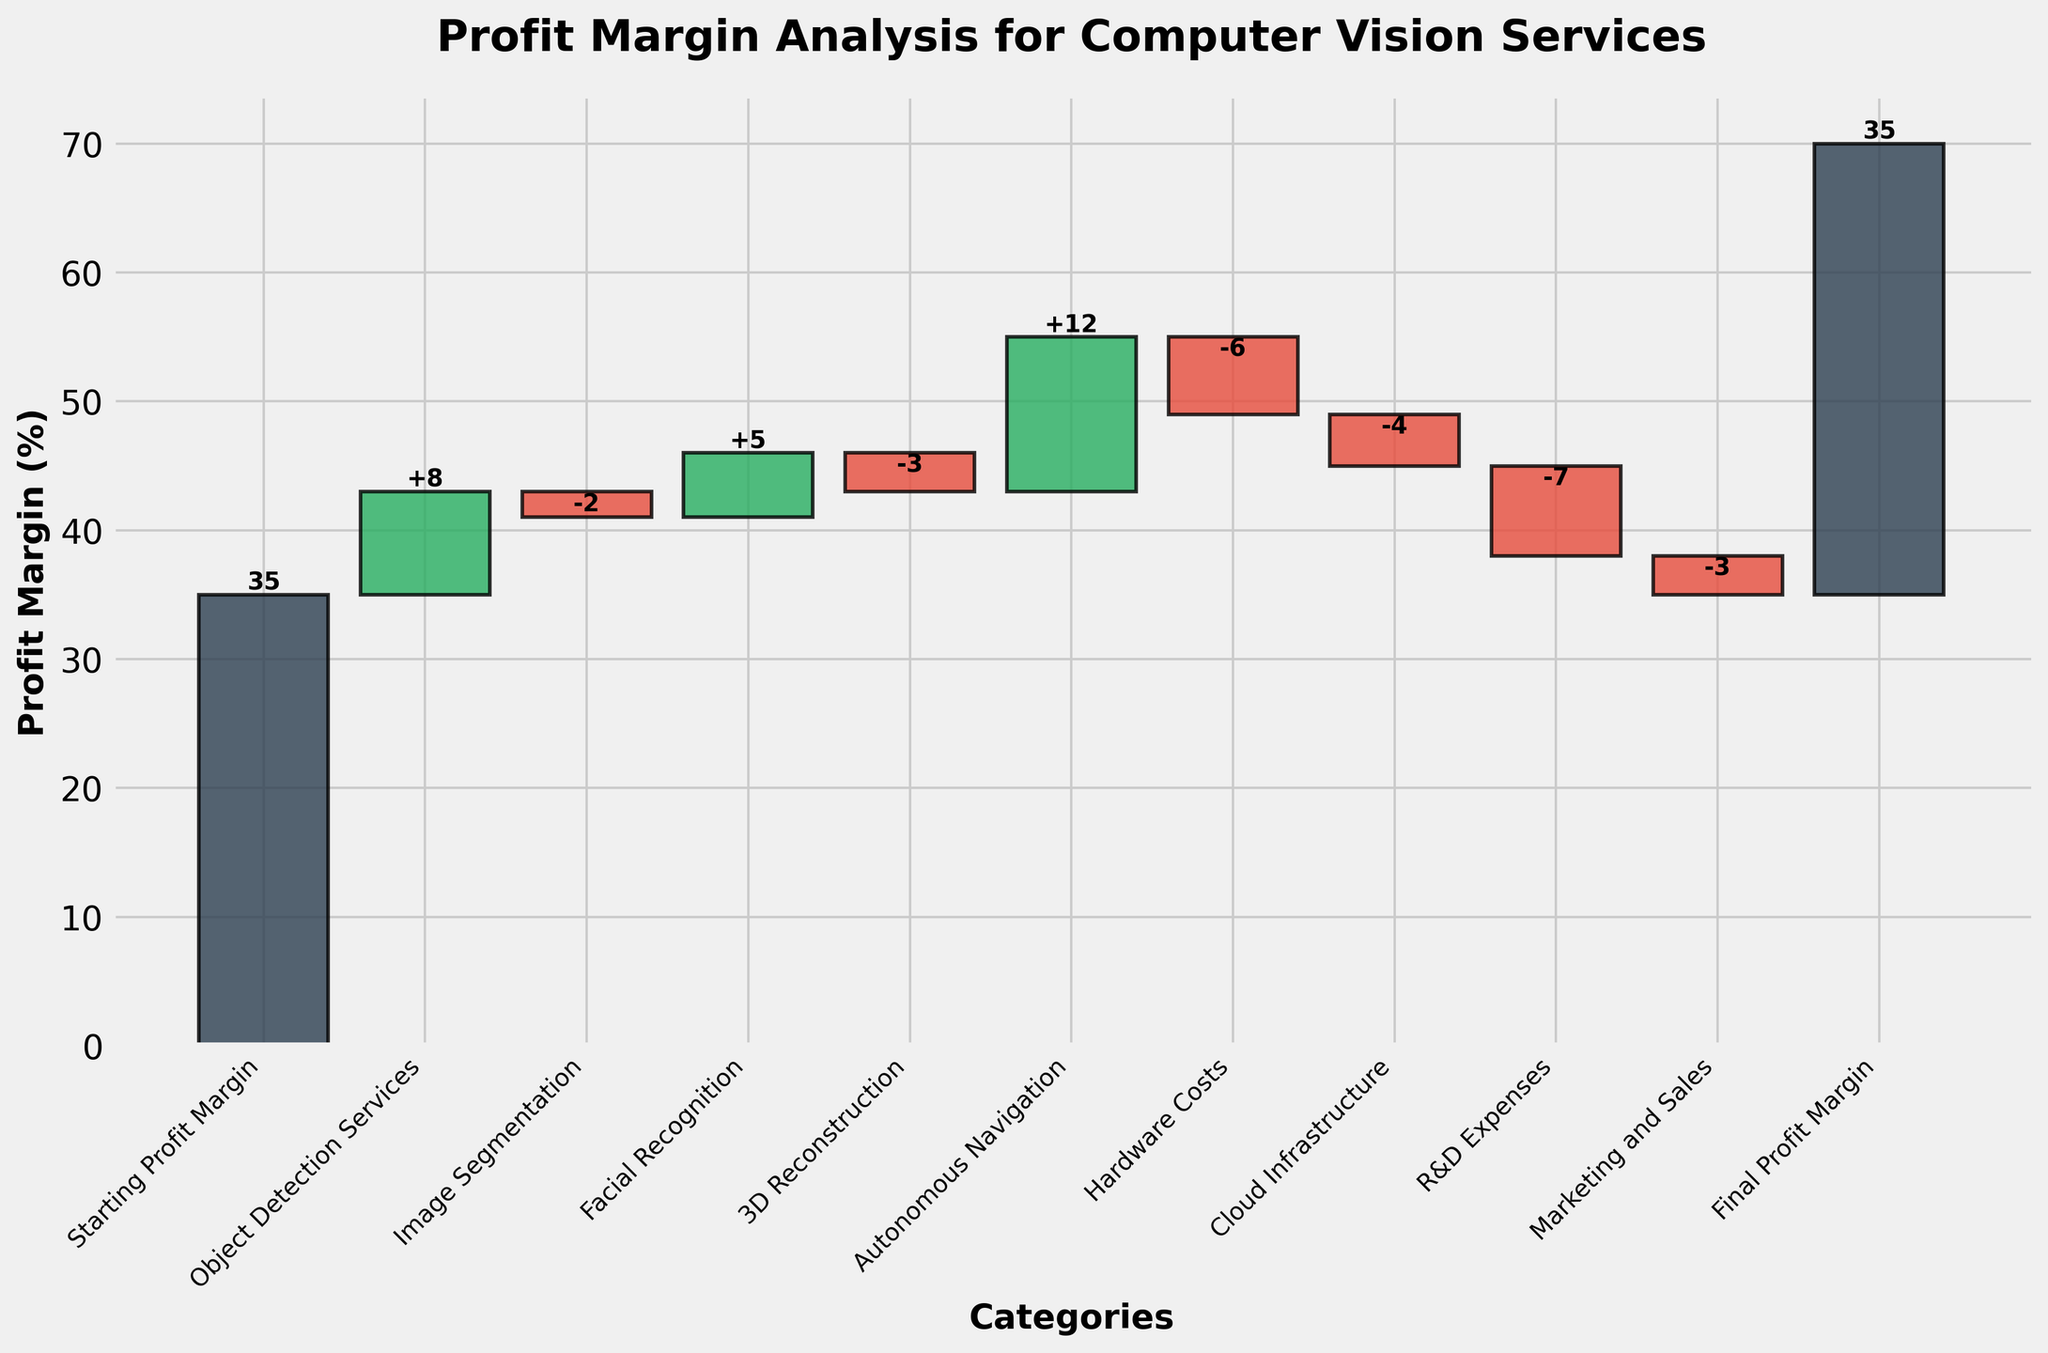What's the starting profit margin? The starting profit margin is given as the first value in the figure, labeled "Starting Profit Margin."
Answer: 35% What is the impact of hardware costs on the profit margin? The decrease due to hardware costs is shown as a red bar labeled "Hardware Costs," with a negative impact of 6%.
Answer: -6% Which category increases the profit margin the most? The highest green bar indicating an increase is labeled "Autonomous Navigation" with a 12% increase.
Answer: Autonomous Navigation What is the final profit margin? The final profit margin is provided as the last value labeled "Final Profit Margin."
Answer: 35% What is the total impact of cloud infrastructure and R&D expenses on the profit margin? The negative impacts are added together: -4% for Cloud Infrastructure and -7% for R&D Expenses. So, -4% + -7% = -11%.
Answer: -11% Which category reduces the profit margin the least? Among the red bars showing reductions, the smallest one is labeled "Marketing and Sales," which reduces the margin by 3%.
Answer: Marketing and Sales How does facial recognition affect the profit margin? The green bar corresponding to "Facial Recognition" shows a positive change of 5% in the profit margin.
Answer: +5% Compare the impact of object detection services and 3D reconstruction on the profit margin. Object Detection Services has an increase of 8% shown by a green bar, while 3D Reconstruction has a reduction of 3% shown by a red bar. 8% > -3%, so Object Detection Services impact is more positive.
Answer: Object Detection Services is more positive How much does marketing and sales contribute to the final profit margin compared to cloud infrastructure? Both are negative impacts (red bars). Marketing and Sales reduce the margin by 3% and Cloud Infrastructure by 4%. Therefore, Marketing and Sales reduce the margin less.
Answer: Marketing and Sales reduce less 